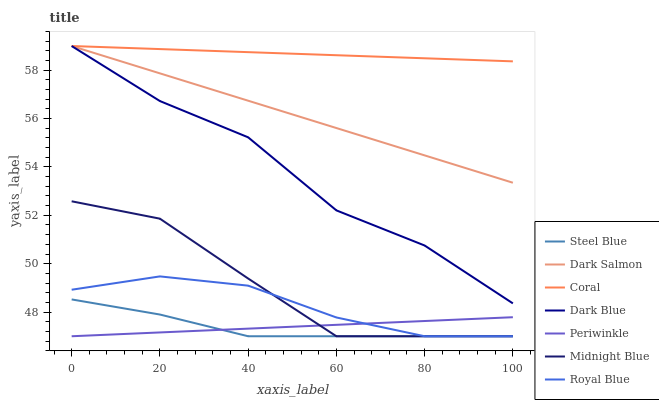Does Steel Blue have the minimum area under the curve?
Answer yes or no. Yes. Does Coral have the maximum area under the curve?
Answer yes or no. Yes. Does Royal Blue have the minimum area under the curve?
Answer yes or no. No. Does Royal Blue have the maximum area under the curve?
Answer yes or no. No. Is Dark Salmon the smoothest?
Answer yes or no. Yes. Is Dark Blue the roughest?
Answer yes or no. Yes. Is Royal Blue the smoothest?
Answer yes or no. No. Is Royal Blue the roughest?
Answer yes or no. No. Does Midnight Blue have the lowest value?
Answer yes or no. Yes. Does Coral have the lowest value?
Answer yes or no. No. Does Dark Blue have the highest value?
Answer yes or no. Yes. Does Royal Blue have the highest value?
Answer yes or no. No. Is Periwinkle less than Coral?
Answer yes or no. Yes. Is Coral greater than Royal Blue?
Answer yes or no. Yes. Does Midnight Blue intersect Royal Blue?
Answer yes or no. Yes. Is Midnight Blue less than Royal Blue?
Answer yes or no. No. Is Midnight Blue greater than Royal Blue?
Answer yes or no. No. Does Periwinkle intersect Coral?
Answer yes or no. No. 